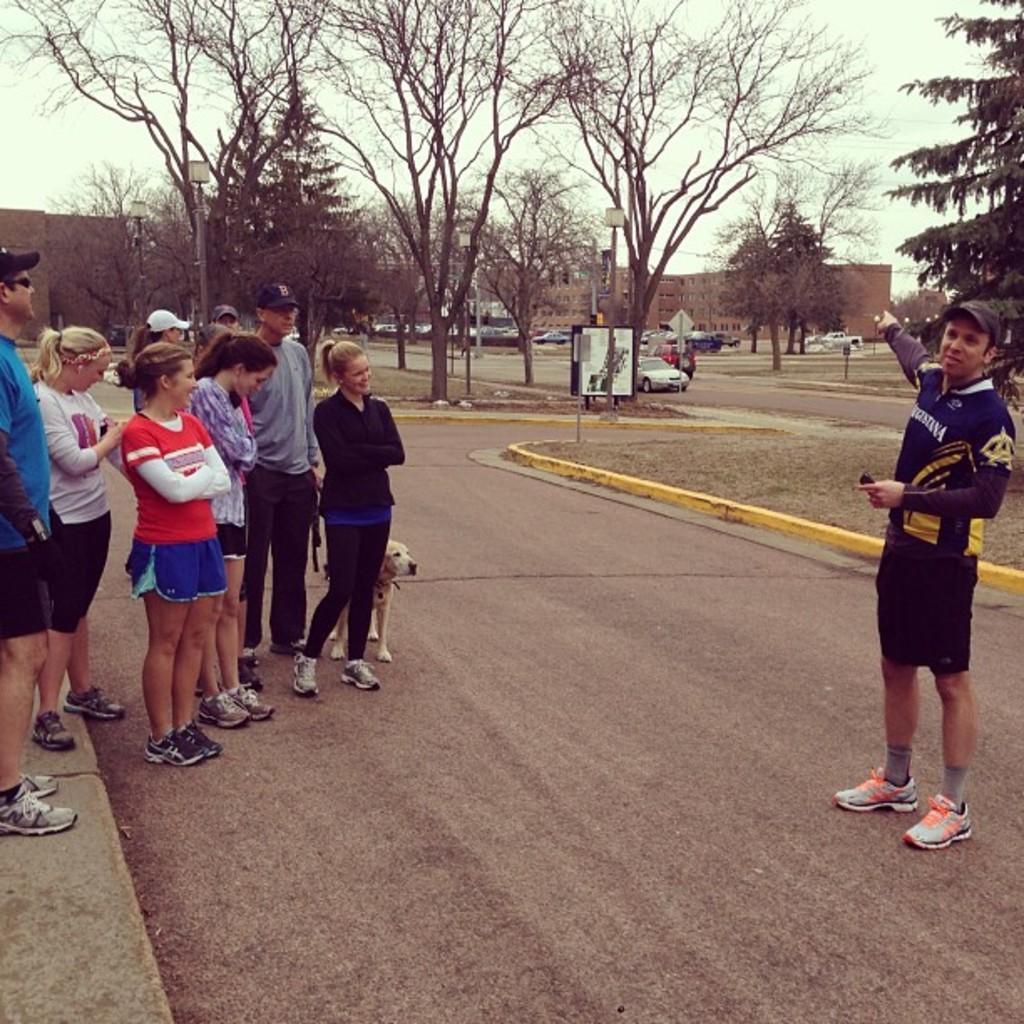Describe this image in one or two sentences. In this picture we can see people standing on the road surrounded by trees and buildings. 